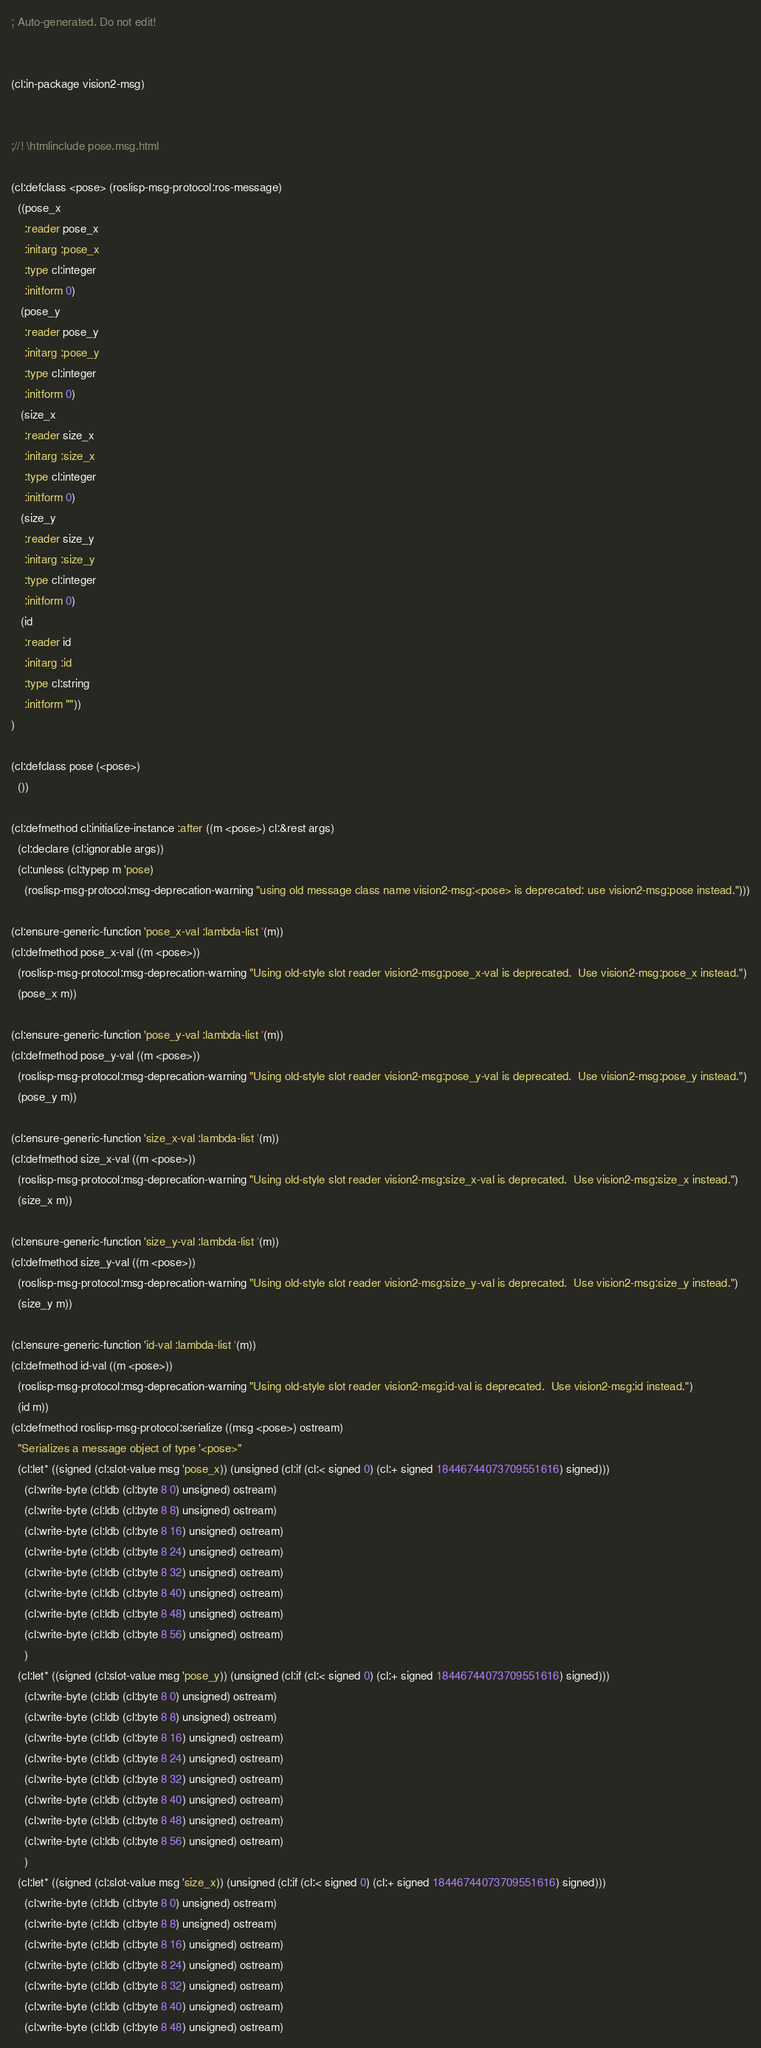Convert code to text. <code><loc_0><loc_0><loc_500><loc_500><_Lisp_>; Auto-generated. Do not edit!


(cl:in-package vision2-msg)


;//! \htmlinclude pose.msg.html

(cl:defclass <pose> (roslisp-msg-protocol:ros-message)
  ((pose_x
    :reader pose_x
    :initarg :pose_x
    :type cl:integer
    :initform 0)
   (pose_y
    :reader pose_y
    :initarg :pose_y
    :type cl:integer
    :initform 0)
   (size_x
    :reader size_x
    :initarg :size_x
    :type cl:integer
    :initform 0)
   (size_y
    :reader size_y
    :initarg :size_y
    :type cl:integer
    :initform 0)
   (id
    :reader id
    :initarg :id
    :type cl:string
    :initform ""))
)

(cl:defclass pose (<pose>)
  ())

(cl:defmethod cl:initialize-instance :after ((m <pose>) cl:&rest args)
  (cl:declare (cl:ignorable args))
  (cl:unless (cl:typep m 'pose)
    (roslisp-msg-protocol:msg-deprecation-warning "using old message class name vision2-msg:<pose> is deprecated: use vision2-msg:pose instead.")))

(cl:ensure-generic-function 'pose_x-val :lambda-list '(m))
(cl:defmethod pose_x-val ((m <pose>))
  (roslisp-msg-protocol:msg-deprecation-warning "Using old-style slot reader vision2-msg:pose_x-val is deprecated.  Use vision2-msg:pose_x instead.")
  (pose_x m))

(cl:ensure-generic-function 'pose_y-val :lambda-list '(m))
(cl:defmethod pose_y-val ((m <pose>))
  (roslisp-msg-protocol:msg-deprecation-warning "Using old-style slot reader vision2-msg:pose_y-val is deprecated.  Use vision2-msg:pose_y instead.")
  (pose_y m))

(cl:ensure-generic-function 'size_x-val :lambda-list '(m))
(cl:defmethod size_x-val ((m <pose>))
  (roslisp-msg-protocol:msg-deprecation-warning "Using old-style slot reader vision2-msg:size_x-val is deprecated.  Use vision2-msg:size_x instead.")
  (size_x m))

(cl:ensure-generic-function 'size_y-val :lambda-list '(m))
(cl:defmethod size_y-val ((m <pose>))
  (roslisp-msg-protocol:msg-deprecation-warning "Using old-style slot reader vision2-msg:size_y-val is deprecated.  Use vision2-msg:size_y instead.")
  (size_y m))

(cl:ensure-generic-function 'id-val :lambda-list '(m))
(cl:defmethod id-val ((m <pose>))
  (roslisp-msg-protocol:msg-deprecation-warning "Using old-style slot reader vision2-msg:id-val is deprecated.  Use vision2-msg:id instead.")
  (id m))
(cl:defmethod roslisp-msg-protocol:serialize ((msg <pose>) ostream)
  "Serializes a message object of type '<pose>"
  (cl:let* ((signed (cl:slot-value msg 'pose_x)) (unsigned (cl:if (cl:< signed 0) (cl:+ signed 18446744073709551616) signed)))
    (cl:write-byte (cl:ldb (cl:byte 8 0) unsigned) ostream)
    (cl:write-byte (cl:ldb (cl:byte 8 8) unsigned) ostream)
    (cl:write-byte (cl:ldb (cl:byte 8 16) unsigned) ostream)
    (cl:write-byte (cl:ldb (cl:byte 8 24) unsigned) ostream)
    (cl:write-byte (cl:ldb (cl:byte 8 32) unsigned) ostream)
    (cl:write-byte (cl:ldb (cl:byte 8 40) unsigned) ostream)
    (cl:write-byte (cl:ldb (cl:byte 8 48) unsigned) ostream)
    (cl:write-byte (cl:ldb (cl:byte 8 56) unsigned) ostream)
    )
  (cl:let* ((signed (cl:slot-value msg 'pose_y)) (unsigned (cl:if (cl:< signed 0) (cl:+ signed 18446744073709551616) signed)))
    (cl:write-byte (cl:ldb (cl:byte 8 0) unsigned) ostream)
    (cl:write-byte (cl:ldb (cl:byte 8 8) unsigned) ostream)
    (cl:write-byte (cl:ldb (cl:byte 8 16) unsigned) ostream)
    (cl:write-byte (cl:ldb (cl:byte 8 24) unsigned) ostream)
    (cl:write-byte (cl:ldb (cl:byte 8 32) unsigned) ostream)
    (cl:write-byte (cl:ldb (cl:byte 8 40) unsigned) ostream)
    (cl:write-byte (cl:ldb (cl:byte 8 48) unsigned) ostream)
    (cl:write-byte (cl:ldb (cl:byte 8 56) unsigned) ostream)
    )
  (cl:let* ((signed (cl:slot-value msg 'size_x)) (unsigned (cl:if (cl:< signed 0) (cl:+ signed 18446744073709551616) signed)))
    (cl:write-byte (cl:ldb (cl:byte 8 0) unsigned) ostream)
    (cl:write-byte (cl:ldb (cl:byte 8 8) unsigned) ostream)
    (cl:write-byte (cl:ldb (cl:byte 8 16) unsigned) ostream)
    (cl:write-byte (cl:ldb (cl:byte 8 24) unsigned) ostream)
    (cl:write-byte (cl:ldb (cl:byte 8 32) unsigned) ostream)
    (cl:write-byte (cl:ldb (cl:byte 8 40) unsigned) ostream)
    (cl:write-byte (cl:ldb (cl:byte 8 48) unsigned) ostream)</code> 